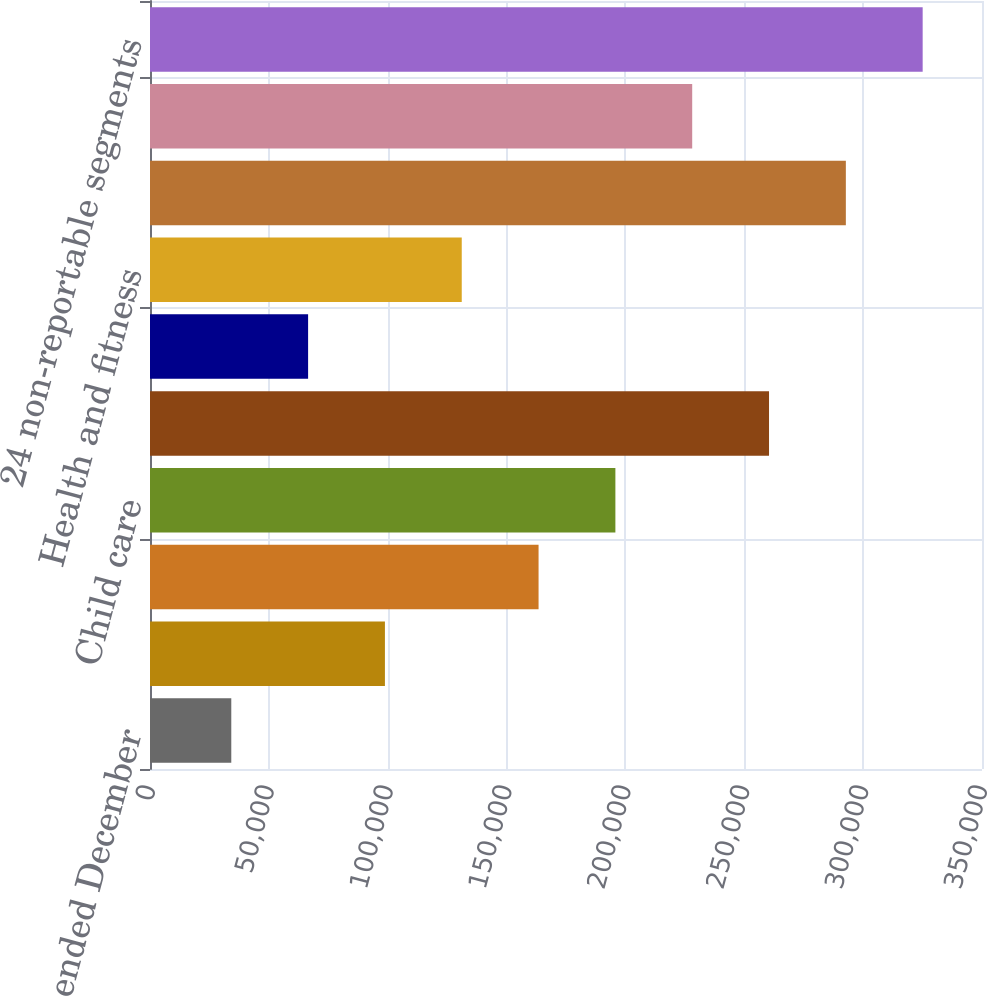Convert chart. <chart><loc_0><loc_0><loc_500><loc_500><bar_chart><fcel>For the years ended December<fcel>Automotive service<fcel>Automotive tire services<fcel>Child care<fcel>Convenience stores<fcel>Drug stores<fcel>Health and fitness<fcel>Restaurants<fcel>Theaters<fcel>24 non-reportable segments<nl><fcel>34193.4<fcel>98826.2<fcel>163459<fcel>195775<fcel>260408<fcel>66509.8<fcel>131143<fcel>292725<fcel>228092<fcel>325041<nl></chart> 